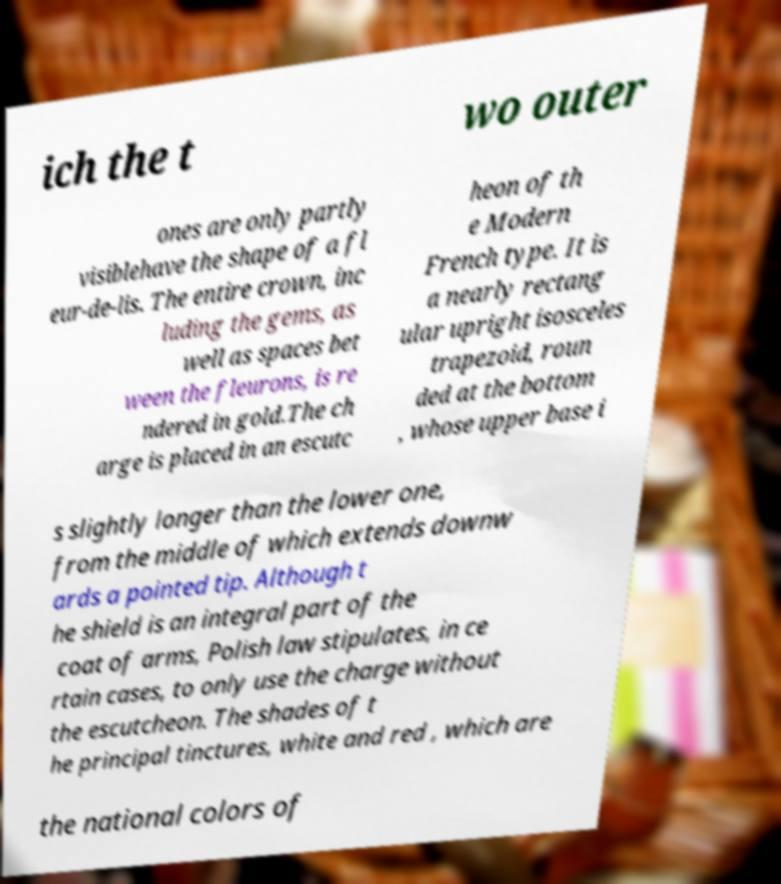Could you assist in decoding the text presented in this image and type it out clearly? ich the t wo outer ones are only partly visiblehave the shape of a fl eur-de-lis. The entire crown, inc luding the gems, as well as spaces bet ween the fleurons, is re ndered in gold.The ch arge is placed in an escutc heon of th e Modern French type. It is a nearly rectang ular upright isosceles trapezoid, roun ded at the bottom , whose upper base i s slightly longer than the lower one, from the middle of which extends downw ards a pointed tip. Although t he shield is an integral part of the coat of arms, Polish law stipulates, in ce rtain cases, to only use the charge without the escutcheon. The shades of t he principal tinctures, white and red , which are the national colors of 